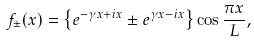Convert formula to latex. <formula><loc_0><loc_0><loc_500><loc_500>f _ { \pm } ( x ) = \left \{ e ^ { - \gamma x + i x } \pm e ^ { \gamma x - i x } \right \} \cos \frac { \pi x } { L } ,</formula> 